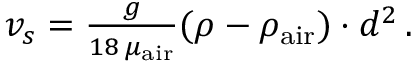Convert formula to latex. <formula><loc_0><loc_0><loc_500><loc_500>\begin{array} { r } { v _ { s } = \frac { g } { 1 8 \, \mu _ { a i r } } ( \rho - \rho _ { a i r } ) \cdot d ^ { 2 } \, . } \end{array}</formula> 